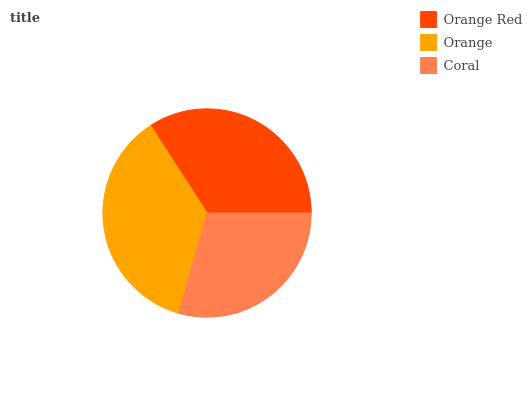Is Coral the minimum?
Answer yes or no. Yes. Is Orange the maximum?
Answer yes or no. Yes. Is Orange the minimum?
Answer yes or no. No. Is Coral the maximum?
Answer yes or no. No. Is Orange greater than Coral?
Answer yes or no. Yes. Is Coral less than Orange?
Answer yes or no. Yes. Is Coral greater than Orange?
Answer yes or no. No. Is Orange less than Coral?
Answer yes or no. No. Is Orange Red the high median?
Answer yes or no. Yes. Is Orange Red the low median?
Answer yes or no. Yes. Is Coral the high median?
Answer yes or no. No. Is Coral the low median?
Answer yes or no. No. 